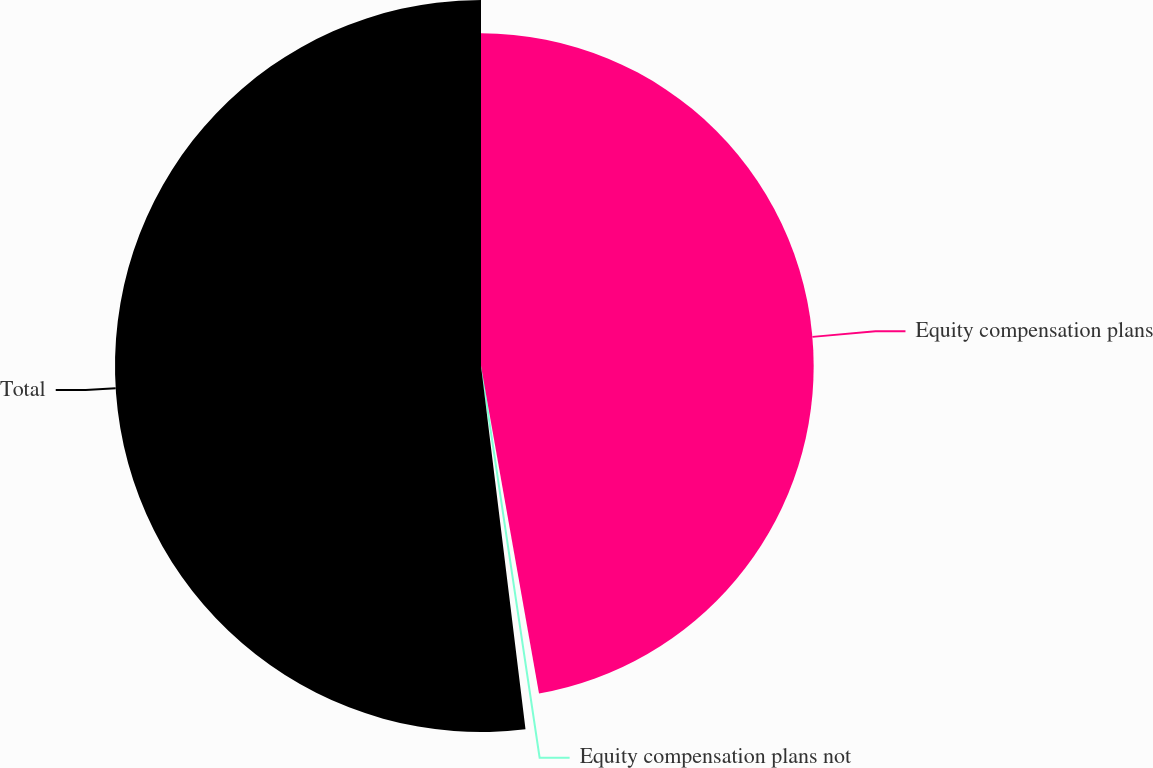Convert chart to OTSL. <chart><loc_0><loc_0><loc_500><loc_500><pie_chart><fcel>Equity compensation plans<fcel>Equity compensation plans not<fcel>Total<nl><fcel>47.21%<fcel>0.85%<fcel>51.94%<nl></chart> 